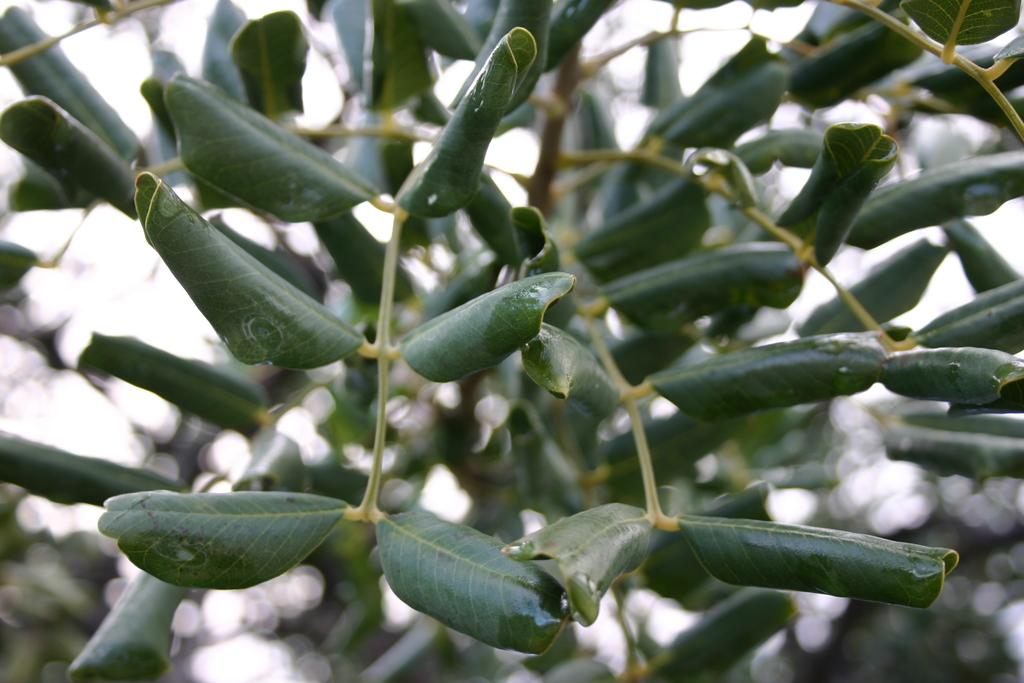What type of vegetation can be seen in the image? There are leaves in the image. Can you describe the background of the image? The background of the image is blurry. How many houses are visible in the image? There are no houses present in the image; it only features leaves and a blurry background. What color is the colorful object in the image? There is no colorful object present in the image; it only features leaves and a blurry background. 